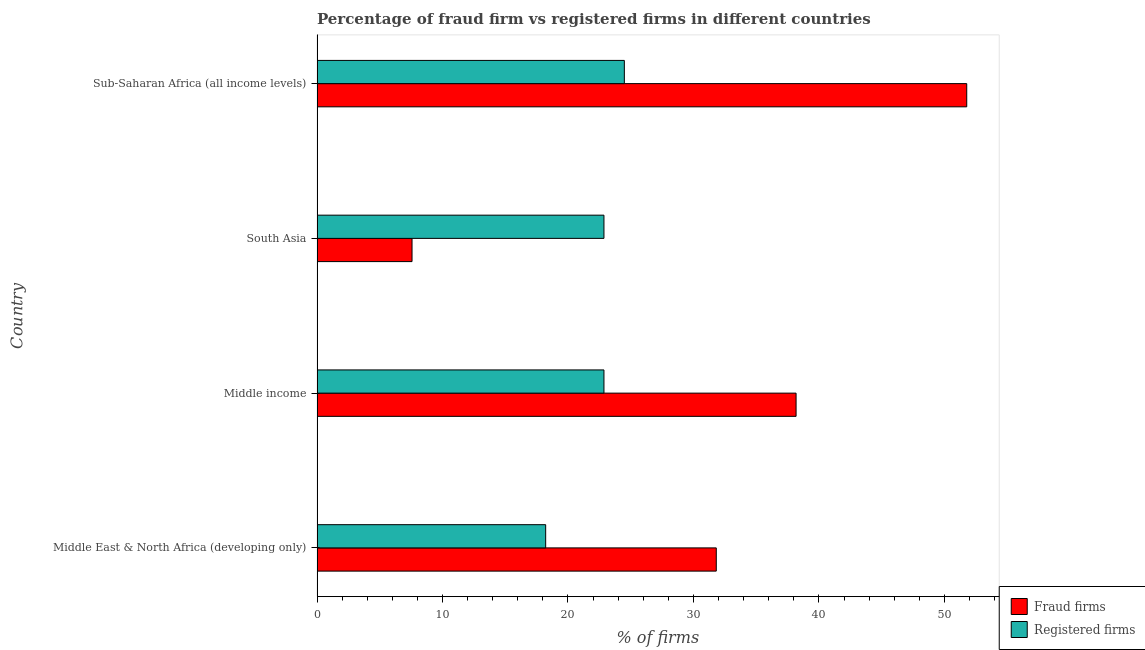How many groups of bars are there?
Keep it short and to the point. 4. Are the number of bars on each tick of the Y-axis equal?
Your answer should be compact. Yes. How many bars are there on the 4th tick from the top?
Offer a terse response. 2. How many bars are there on the 1st tick from the bottom?
Offer a very short reply. 2. What is the label of the 3rd group of bars from the top?
Keep it short and to the point. Middle income. In how many cases, is the number of bars for a given country not equal to the number of legend labels?
Ensure brevity in your answer.  0. What is the percentage of registered firms in South Asia?
Provide a short and direct response. 22.87. Across all countries, what is the maximum percentage of registered firms?
Ensure brevity in your answer.  24.49. Across all countries, what is the minimum percentage of fraud firms?
Provide a short and direct response. 7.57. In which country was the percentage of registered firms maximum?
Your answer should be compact. Sub-Saharan Africa (all income levels). In which country was the percentage of registered firms minimum?
Offer a terse response. Middle East & North Africa (developing only). What is the total percentage of fraud firms in the graph?
Provide a succinct answer. 129.35. What is the difference between the percentage of fraud firms in South Asia and that in Sub-Saharan Africa (all income levels)?
Provide a short and direct response. -44.21. What is the difference between the percentage of registered firms in Sub-Saharan Africa (all income levels) and the percentage of fraud firms in Middle East & North Africa (developing only)?
Keep it short and to the point. -7.33. What is the average percentage of registered firms per country?
Your answer should be compact. 22.11. What is the difference between the percentage of fraud firms and percentage of registered firms in Middle East & North Africa (developing only)?
Make the answer very short. 13.6. In how many countries, is the percentage of fraud firms greater than 2 %?
Your response must be concise. 4. What is the ratio of the percentage of registered firms in Middle income to that in Sub-Saharan Africa (all income levels)?
Your response must be concise. 0.93. Is the difference between the percentage of registered firms in South Asia and Sub-Saharan Africa (all income levels) greater than the difference between the percentage of fraud firms in South Asia and Sub-Saharan Africa (all income levels)?
Your answer should be compact. Yes. What is the difference between the highest and the second highest percentage of registered firms?
Give a very brief answer. 1.63. What is the difference between the highest and the lowest percentage of fraud firms?
Offer a terse response. 44.21. Is the sum of the percentage of fraud firms in Middle East & North Africa (developing only) and Sub-Saharan Africa (all income levels) greater than the maximum percentage of registered firms across all countries?
Your answer should be compact. Yes. What does the 1st bar from the top in Middle East & North Africa (developing only) represents?
Provide a succinct answer. Registered firms. What does the 2nd bar from the bottom in Middle East & North Africa (developing only) represents?
Your response must be concise. Registered firms. How many bars are there?
Provide a short and direct response. 8. How many countries are there in the graph?
Offer a very short reply. 4. What is the difference between two consecutive major ticks on the X-axis?
Give a very brief answer. 10. Are the values on the major ticks of X-axis written in scientific E-notation?
Provide a succinct answer. No. Does the graph contain grids?
Your answer should be very brief. No. Where does the legend appear in the graph?
Offer a terse response. Bottom right. How are the legend labels stacked?
Your answer should be very brief. Vertical. What is the title of the graph?
Your answer should be very brief. Percentage of fraud firm vs registered firms in different countries. What is the label or title of the X-axis?
Offer a very short reply. % of firms. What is the label or title of the Y-axis?
Ensure brevity in your answer.  Country. What is the % of firms of Fraud firms in Middle East & North Africa (developing only)?
Provide a short and direct response. 31.82. What is the % of firms of Registered firms in Middle East & North Africa (developing only)?
Make the answer very short. 18.22. What is the % of firms of Fraud firms in Middle income?
Ensure brevity in your answer.  38.18. What is the % of firms in Registered firms in Middle income?
Provide a succinct answer. 22.87. What is the % of firms in Fraud firms in South Asia?
Make the answer very short. 7.57. What is the % of firms of Registered firms in South Asia?
Provide a short and direct response. 22.87. What is the % of firms in Fraud firms in Sub-Saharan Africa (all income levels)?
Give a very brief answer. 51.78. What is the % of firms of Registered firms in Sub-Saharan Africa (all income levels)?
Offer a very short reply. 24.49. Across all countries, what is the maximum % of firms in Fraud firms?
Make the answer very short. 51.78. Across all countries, what is the maximum % of firms in Registered firms?
Provide a short and direct response. 24.49. Across all countries, what is the minimum % of firms in Fraud firms?
Your response must be concise. 7.57. Across all countries, what is the minimum % of firms of Registered firms?
Provide a short and direct response. 18.22. What is the total % of firms of Fraud firms in the graph?
Offer a very short reply. 129.35. What is the total % of firms of Registered firms in the graph?
Offer a very short reply. 88.45. What is the difference between the % of firms of Fraud firms in Middle East & North Africa (developing only) and that in Middle income?
Provide a short and direct response. -6.36. What is the difference between the % of firms of Registered firms in Middle East & North Africa (developing only) and that in Middle income?
Offer a terse response. -4.64. What is the difference between the % of firms in Fraud firms in Middle East & North Africa (developing only) and that in South Asia?
Offer a very short reply. 24.25. What is the difference between the % of firms of Registered firms in Middle East & North Africa (developing only) and that in South Asia?
Give a very brief answer. -4.64. What is the difference between the % of firms in Fraud firms in Middle East & North Africa (developing only) and that in Sub-Saharan Africa (all income levels)?
Your answer should be very brief. -19.96. What is the difference between the % of firms of Registered firms in Middle East & North Africa (developing only) and that in Sub-Saharan Africa (all income levels)?
Offer a terse response. -6.27. What is the difference between the % of firms of Fraud firms in Middle income and that in South Asia?
Give a very brief answer. 30.61. What is the difference between the % of firms of Registered firms in Middle income and that in South Asia?
Ensure brevity in your answer.  0. What is the difference between the % of firms in Fraud firms in Middle income and that in Sub-Saharan Africa (all income levels)?
Give a very brief answer. -13.6. What is the difference between the % of firms in Registered firms in Middle income and that in Sub-Saharan Africa (all income levels)?
Your answer should be compact. -1.63. What is the difference between the % of firms in Fraud firms in South Asia and that in Sub-Saharan Africa (all income levels)?
Offer a very short reply. -44.21. What is the difference between the % of firms of Registered firms in South Asia and that in Sub-Saharan Africa (all income levels)?
Give a very brief answer. -1.63. What is the difference between the % of firms in Fraud firms in Middle East & North Africa (developing only) and the % of firms in Registered firms in Middle income?
Give a very brief answer. 8.95. What is the difference between the % of firms in Fraud firms in Middle East & North Africa (developing only) and the % of firms in Registered firms in South Asia?
Provide a succinct answer. 8.95. What is the difference between the % of firms of Fraud firms in Middle East & North Africa (developing only) and the % of firms of Registered firms in Sub-Saharan Africa (all income levels)?
Your answer should be compact. 7.33. What is the difference between the % of firms of Fraud firms in Middle income and the % of firms of Registered firms in South Asia?
Your response must be concise. 15.31. What is the difference between the % of firms of Fraud firms in Middle income and the % of firms of Registered firms in Sub-Saharan Africa (all income levels)?
Your response must be concise. 13.69. What is the difference between the % of firms in Fraud firms in South Asia and the % of firms in Registered firms in Sub-Saharan Africa (all income levels)?
Keep it short and to the point. -16.92. What is the average % of firms in Fraud firms per country?
Provide a short and direct response. 32.34. What is the average % of firms in Registered firms per country?
Make the answer very short. 22.11. What is the difference between the % of firms in Fraud firms and % of firms in Registered firms in Middle East & North Africa (developing only)?
Provide a short and direct response. 13.6. What is the difference between the % of firms in Fraud firms and % of firms in Registered firms in Middle income?
Ensure brevity in your answer.  15.31. What is the difference between the % of firms of Fraud firms and % of firms of Registered firms in South Asia?
Keep it short and to the point. -15.3. What is the difference between the % of firms of Fraud firms and % of firms of Registered firms in Sub-Saharan Africa (all income levels)?
Keep it short and to the point. 27.29. What is the ratio of the % of firms of Fraud firms in Middle East & North Africa (developing only) to that in Middle income?
Your answer should be compact. 0.83. What is the ratio of the % of firms in Registered firms in Middle East & North Africa (developing only) to that in Middle income?
Your answer should be compact. 0.8. What is the ratio of the % of firms in Fraud firms in Middle East & North Africa (developing only) to that in South Asia?
Give a very brief answer. 4.2. What is the ratio of the % of firms of Registered firms in Middle East & North Africa (developing only) to that in South Asia?
Your response must be concise. 0.8. What is the ratio of the % of firms in Fraud firms in Middle East & North Africa (developing only) to that in Sub-Saharan Africa (all income levels)?
Make the answer very short. 0.61. What is the ratio of the % of firms of Registered firms in Middle East & North Africa (developing only) to that in Sub-Saharan Africa (all income levels)?
Offer a very short reply. 0.74. What is the ratio of the % of firms in Fraud firms in Middle income to that in South Asia?
Give a very brief answer. 5.04. What is the ratio of the % of firms of Fraud firms in Middle income to that in Sub-Saharan Africa (all income levels)?
Your answer should be very brief. 0.74. What is the ratio of the % of firms of Registered firms in Middle income to that in Sub-Saharan Africa (all income levels)?
Offer a very short reply. 0.93. What is the ratio of the % of firms of Fraud firms in South Asia to that in Sub-Saharan Africa (all income levels)?
Your response must be concise. 0.15. What is the ratio of the % of firms in Registered firms in South Asia to that in Sub-Saharan Africa (all income levels)?
Offer a terse response. 0.93. What is the difference between the highest and the second highest % of firms in Fraud firms?
Your response must be concise. 13.6. What is the difference between the highest and the second highest % of firms of Registered firms?
Offer a terse response. 1.63. What is the difference between the highest and the lowest % of firms in Fraud firms?
Offer a terse response. 44.21. What is the difference between the highest and the lowest % of firms in Registered firms?
Provide a short and direct response. 6.27. 